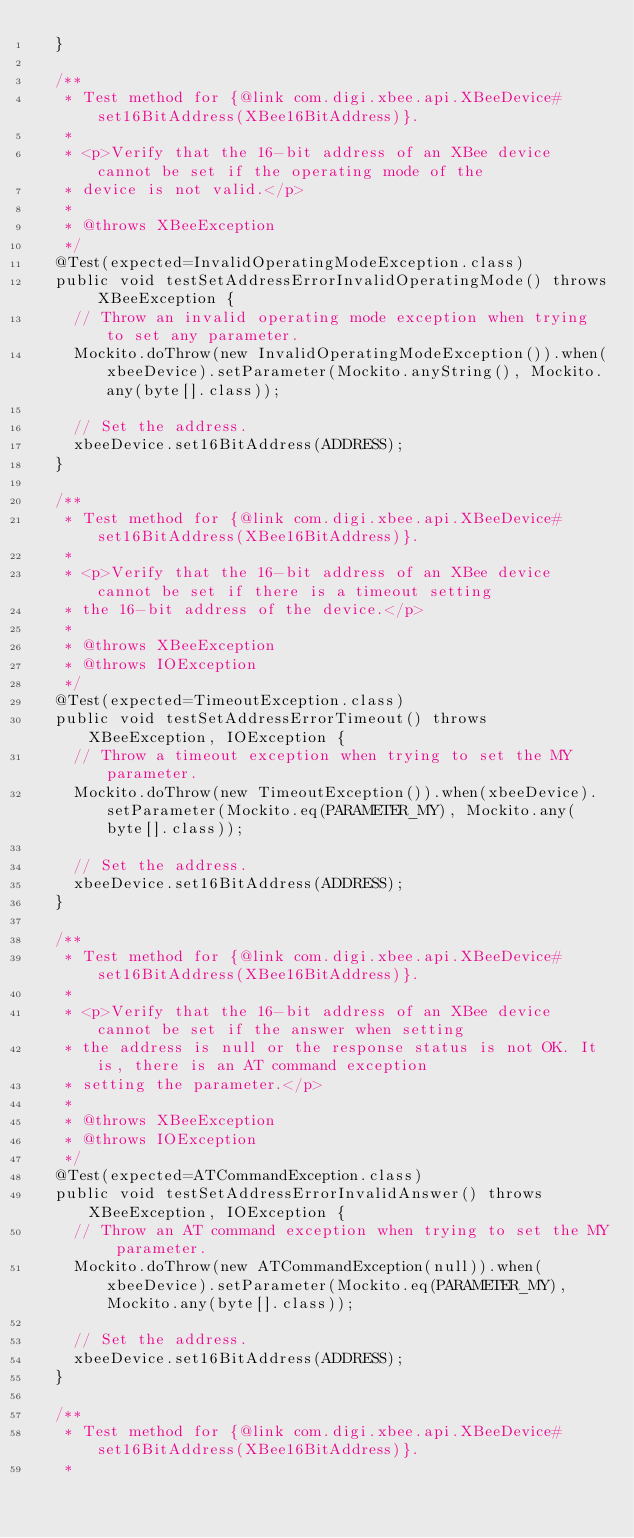<code> <loc_0><loc_0><loc_500><loc_500><_Java_>	}
	
	/**
	 * Test method for {@link com.digi.xbee.api.XBeeDevice#set16BitAddress(XBee16BitAddress)}.
	 * 
	 * <p>Verify that the 16-bit address of an XBee device cannot be set if the operating mode of the 
	 * device is not valid.</p>
	 * 
	 * @throws XBeeException
	 */
	@Test(expected=InvalidOperatingModeException.class)
	public void testSetAddressErrorInvalidOperatingMode() throws XBeeException {
		// Throw an invalid operating mode exception when trying to set any parameter.
		Mockito.doThrow(new InvalidOperatingModeException()).when(xbeeDevice).setParameter(Mockito.anyString(), Mockito.any(byte[].class));
		
		// Set the address.
		xbeeDevice.set16BitAddress(ADDRESS);
	}
	
	/**
	 * Test method for {@link com.digi.xbee.api.XBeeDevice#set16BitAddress(XBee16BitAddress)}.
	 * 
	 * <p>Verify that the 16-bit address of an XBee device cannot be set if there is a timeout setting 
	 * the 16-bit address of the device.</p>
	 * 
	 * @throws XBeeException
	 * @throws IOException 
	 */
	@Test(expected=TimeoutException.class)
	public void testSetAddressErrorTimeout() throws XBeeException, IOException {
		// Throw a timeout exception when trying to set the MY parameter.
		Mockito.doThrow(new TimeoutException()).when(xbeeDevice).setParameter(Mockito.eq(PARAMETER_MY), Mockito.any(byte[].class));
		
		// Set the address.
		xbeeDevice.set16BitAddress(ADDRESS);
	}
	
	/**
	 * Test method for {@link com.digi.xbee.api.XBeeDevice#set16BitAddress(XBee16BitAddress)}.
	 * 
	 * <p>Verify that the 16-bit address of an XBee device cannot be set if the answer when setting 
	 * the address is null or the response status is not OK. It is, there is an AT command exception 
	 * setting the parameter.</p>
	 * 
	 * @throws XBeeException
	 * @throws IOException 
	 */
	@Test(expected=ATCommandException.class)
	public void testSetAddressErrorInvalidAnswer() throws XBeeException, IOException {
		// Throw an AT command exception when trying to set the MY parameter.
		Mockito.doThrow(new ATCommandException(null)).when(xbeeDevice).setParameter(Mockito.eq(PARAMETER_MY), Mockito.any(byte[].class));
		
		// Set the address.
		xbeeDevice.set16BitAddress(ADDRESS);
	}
	
	/**
	 * Test method for {@link com.digi.xbee.api.XBeeDevice#set16BitAddress(XBee16BitAddress)}.
	 * </code> 